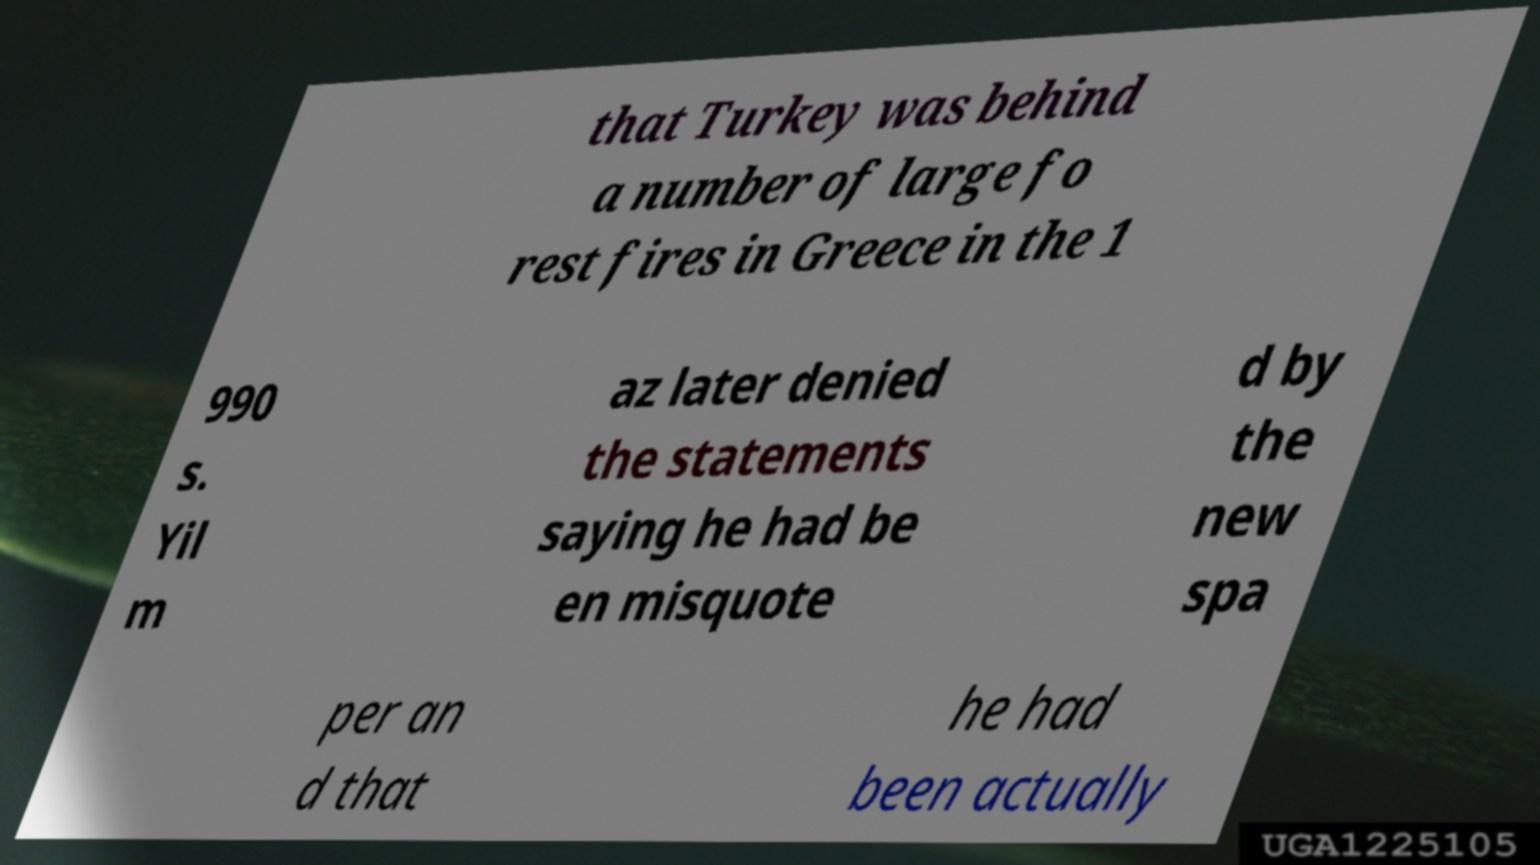Can you read and provide the text displayed in the image?This photo seems to have some interesting text. Can you extract and type it out for me? that Turkey was behind a number of large fo rest fires in Greece in the 1 990 s. Yil m az later denied the statements saying he had be en misquote d by the new spa per an d that he had been actually 